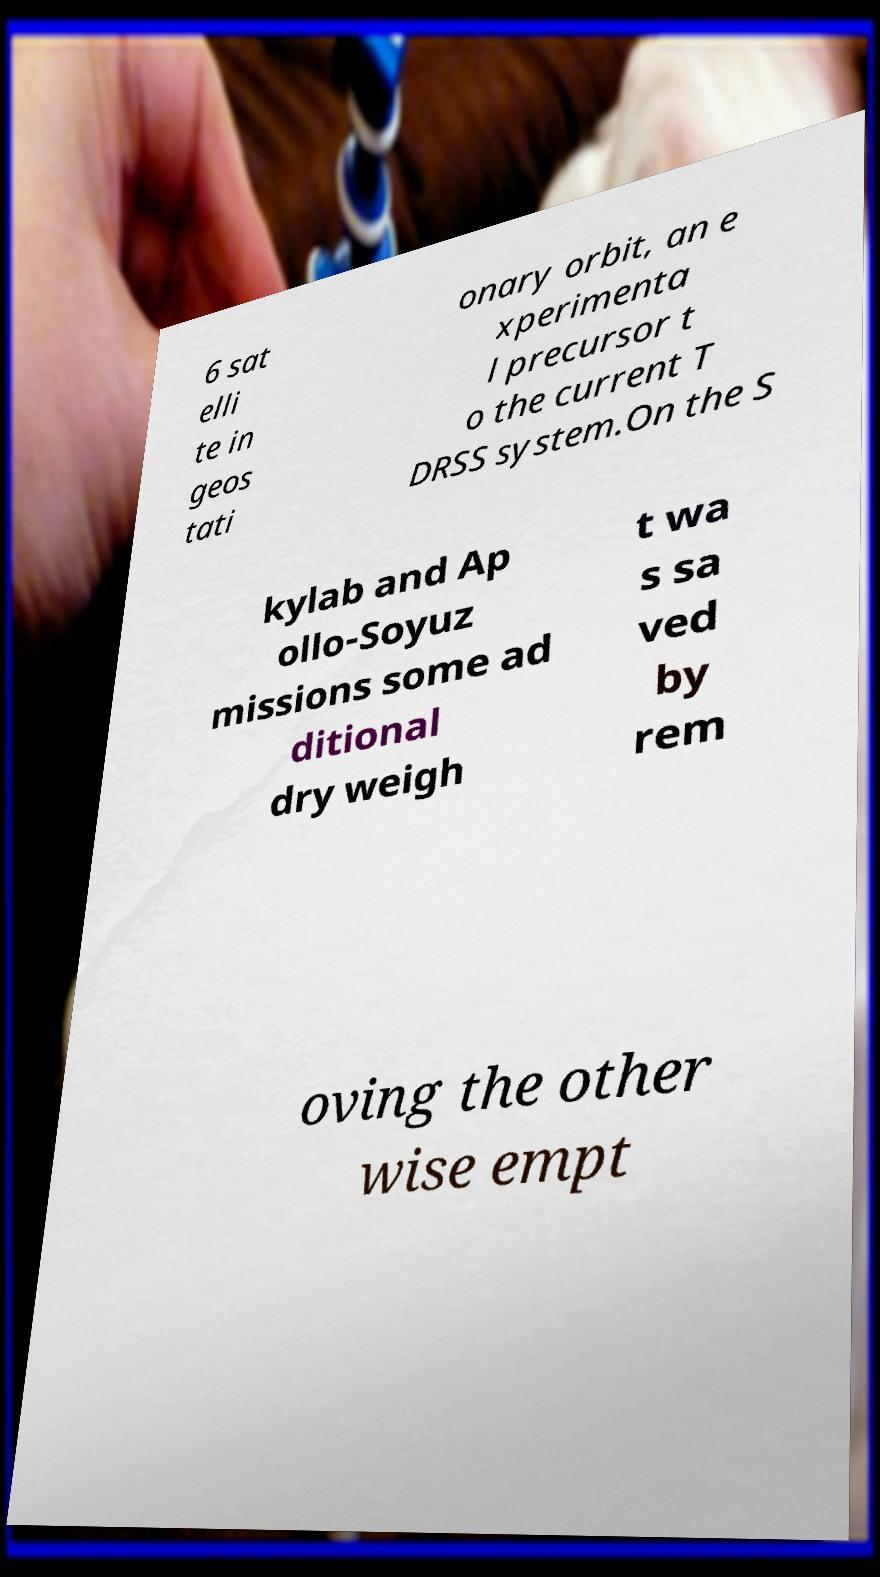Could you assist in decoding the text presented in this image and type it out clearly? 6 sat elli te in geos tati onary orbit, an e xperimenta l precursor t o the current T DRSS system.On the S kylab and Ap ollo-Soyuz missions some ad ditional dry weigh t wa s sa ved by rem oving the other wise empt 